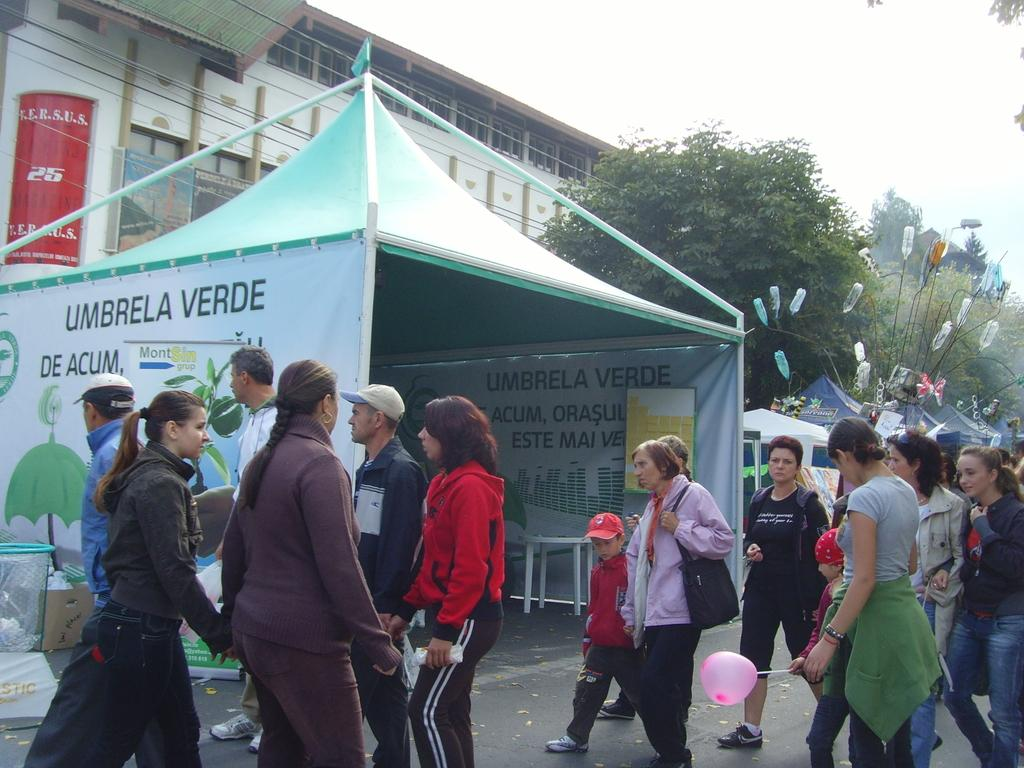What type of natural elements can be seen in the image? There are trees in the image. What type of man-made structure is present in the image? There is a building in the image. What type of temporary structures are present in the image? There are stalls in the image. What type of signage is present in the image? There are boards in the image. What type of objects are present in the image? There are objects in the image. What type of activity can be seen involving people in the image? People are walking on the road in the image. Can you tell me how many turkeys are swimming in the image? There are no turkeys present in the image, and they cannot swim as they are not aquatic animals. What type of drain is visible in the image? There is no drain present in the image. 